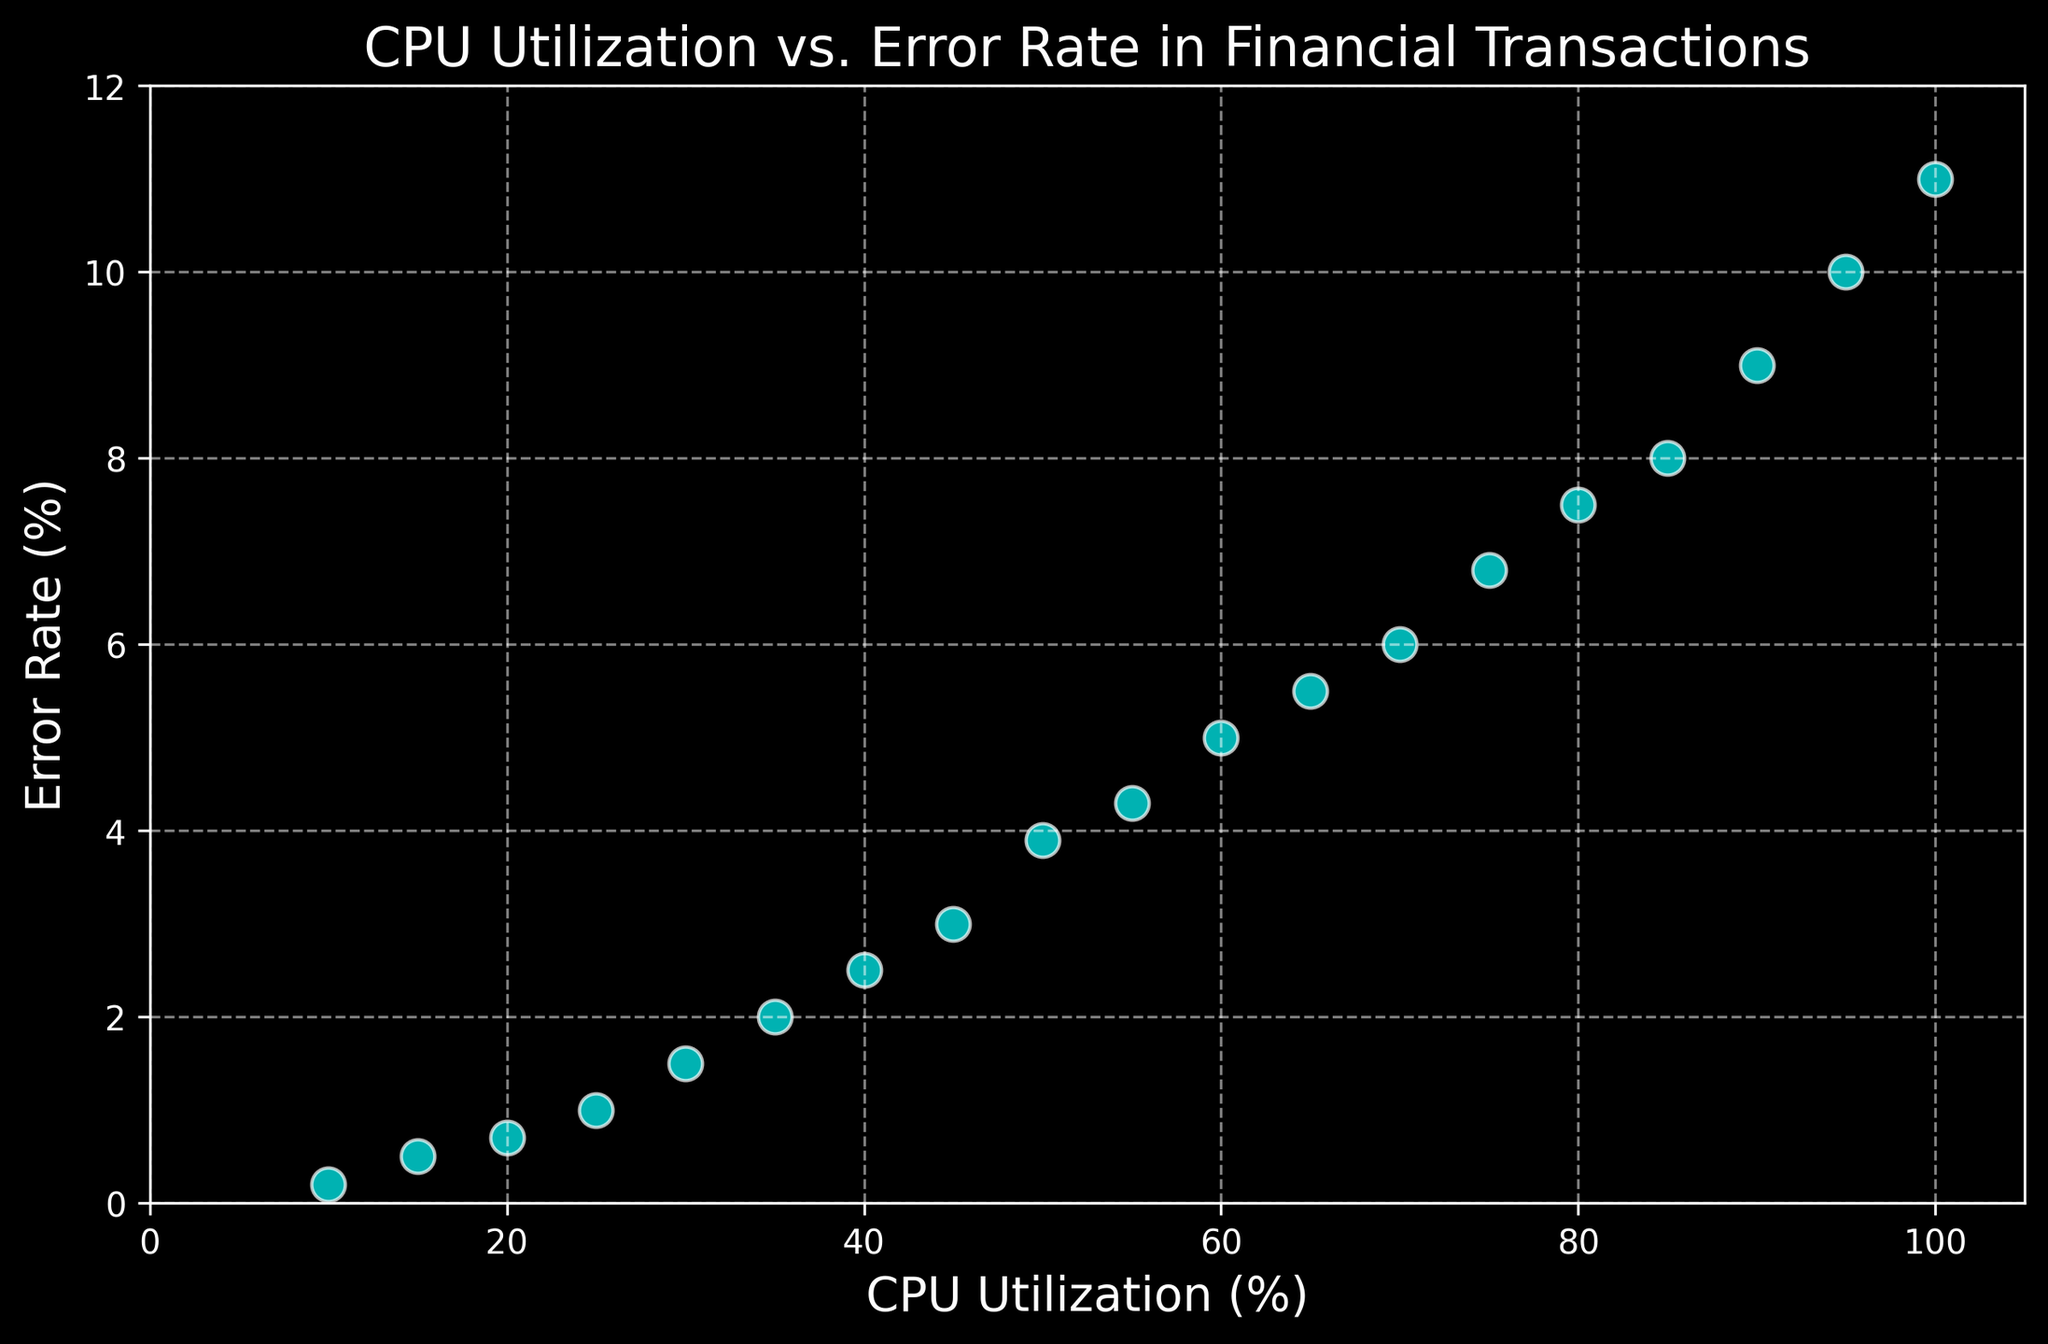What trend can be observed between CPU Utilization and Error Rate? As the CPU Utilization increases, the Error Rate also increases. This indicates a strong positive correlation between the two variables. The Error Rate escalates more rapidly after about 50% CPU Utilization.
Answer: Positive correlation Which range of CPU Utilization shows the most rapid increase in Error Rate? By observing the plot, the most rapid increase in Error Rate appears when CPU Utilization is between 45% and 55%. In this range, the Error Rate jumps from 3.0% to 4.3%.
Answer: Between 45% and 55% Compare the Error Rate at 30% CPU Utilization with that at 60% CPU Utilization. Which one is higher? At 30% CPU Utilization, the Error Rate is around 1.5%. At 60% CPU Utilization, the Error Rate is about 5.0%. Therefore, the Error Rate at 60% CPU Utilization is higher.
Answer: 60% CPU Utilization What is the difference in Error Rate between the maximum and minimum CPU Utilization? The Error Rate at maximum CPU Utilization (100%) is 11.0%, and the Error Rate at minimum CPU Utilization (10%) is 0.2%. The difference is 11.0% - 0.2% = 10.8%.
Answer: 10.8% Is there any point where the Error Rate suddenly spikes? Yes, there is a noticeable spike in Error Rate starting from around 50% CPU Utilization, where it increases sharply from 3.9% to 4.3%.
Answer: Yes At what CPU Utilization do we first see the Error Rate exceed 5%? By inspecting the plot, the Error Rate exceeds 5% at 60% CPU Utilization.
Answer: 60% CPU Utilization What is the visual attribute of markers used in the plot? The markers in the plot are cyan in color, with white edges, and are circular in shape. They have a transparency level (alpha) of 0.7.
Answer: Cyan, circular, transparent How does the Error Rate change as CPU Utilization moves from 40% to 70%? The Error Rate increases from 2.5% at 40% CPU Utilization to 6.0% at 70% CPU Utilization. This indicates a steady rise in Error Rate over this range of CPU Utilization.
Answer: Increases What is the average Error Rate when CPU Utilization is at or above 90%? The Error Rates at CPU Utilization 90%, 95%, and 100% are 9.0%, 10.0%, and 11.0% respectively. The average Error Rate is (9.0 + 10.0 + 11.0) / 3 = 10.0%.
Answer: 10.0% Between which two neighboring CPU Utilization points is the largest increase in Error Rate? The largest increase in Error Rate between neighboring CPU Utilization points occurs between 90% and 95%, where the Error Rate increases from 9.0% to 10.0%, an increase of 1.0%.
Answer: Between 90% and 95% 